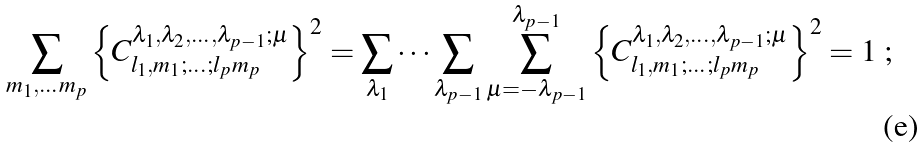Convert formula to latex. <formula><loc_0><loc_0><loc_500><loc_500>\sum _ { m _ { 1 } , \dots m _ { p } } \left \{ C _ { l _ { 1 } , m _ { 1 } ; \dots ; l _ { p } m _ { p } } ^ { \lambda _ { 1 } , \lambda _ { 2 } , \dots , \lambda _ { p - 1 } ; \mu } \right \} ^ { 2 } = \sum _ { \lambda _ { 1 } } \dots \sum _ { \lambda _ { p - 1 } } \sum _ { \mu = - \lambda _ { p - 1 } } ^ { \lambda _ { p - 1 } } \left \{ C _ { l _ { 1 } , m _ { 1 } ; \dots ; l _ { p } m _ { p } } ^ { \lambda _ { 1 } , \lambda _ { 2 } , \dots , \lambda _ { p - 1 } ; \mu } \right \} ^ { 2 } = 1 \text { ;}</formula> 